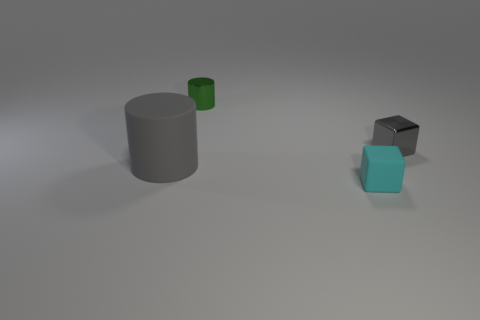Is the color of the big cylinder the same as the metal block?
Offer a very short reply. Yes. Is the number of small matte objects that are in front of the tiny cyan block the same as the number of objects that are behind the small gray object?
Keep it short and to the point. No. What is the color of the tiny cylinder?
Keep it short and to the point. Green. What number of things are either cubes that are to the right of the small cyan matte object or tiny red rubber balls?
Your answer should be very brief. 1. Is the size of the thing in front of the gray rubber cylinder the same as the cylinder behind the small gray cube?
Give a very brief answer. Yes. What number of things are either things that are in front of the gray block or things behind the large object?
Ensure brevity in your answer.  4. Is the material of the tiny cyan thing the same as the gray thing right of the green cylinder?
Give a very brief answer. No. What is the shape of the object that is in front of the small cylinder and to the left of the small cyan matte object?
Make the answer very short. Cylinder. How many other objects are the same color as the rubber cube?
Ensure brevity in your answer.  0. The cyan matte thing is what shape?
Provide a short and direct response. Cube. 